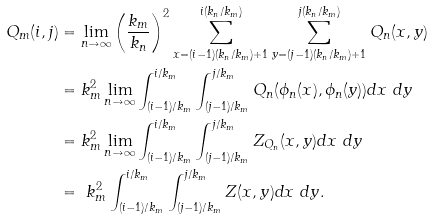Convert formula to latex. <formula><loc_0><loc_0><loc_500><loc_500>Q _ { m } ( i , j ) & = \lim _ { n \to \infty } \left ( \frac { k _ { m } } { k _ { n } } \right ) ^ { 2 } \sum _ { x = ( i - 1 ) ( k _ { n } / k _ { m } ) + 1 } ^ { i ( k _ { n } / k _ { m } ) } \sum _ { y = ( j - 1 ) ( k _ { n } / k _ { m } ) + 1 } ^ { j ( k _ { n } / k _ { m } ) } Q _ { n } ( x , y ) \\ & = k _ { m } ^ { 2 } \lim _ { n \to \infty } \int _ { ( i - 1 ) / k _ { m } } ^ { i / k _ { m } } \int _ { ( j - 1 ) / k _ { m } } ^ { j / k _ { m } } Q _ { n } ( \phi _ { n } ( x ) , \phi _ { n } ( y ) ) d x \ d y \\ & = k _ { m } ^ { 2 } \lim _ { n \to \infty } \int _ { ( i - 1 ) / k _ { m } } ^ { i / k _ { m } } \int _ { ( j - 1 ) / k _ { m } } ^ { j / k _ { m } } Z _ { Q _ { n } } ( x , y ) d x \ d y \\ & = \ k _ { m } ^ { 2 } \int _ { ( i - 1 ) / k _ { m } } ^ { i / k _ { m } } \int _ { ( j - 1 ) / k _ { m } } ^ { j / k _ { m } } Z ( x , y ) d x \ d y .</formula> 